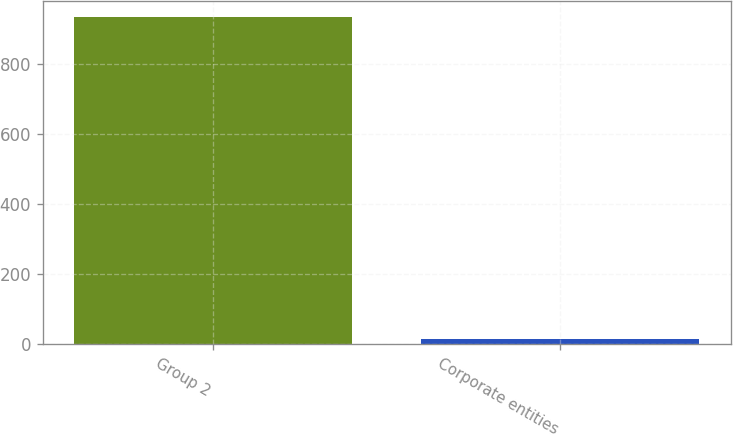Convert chart. <chart><loc_0><loc_0><loc_500><loc_500><bar_chart><fcel>Group 2<fcel>Corporate entities<nl><fcel>935.2<fcel>16.2<nl></chart> 